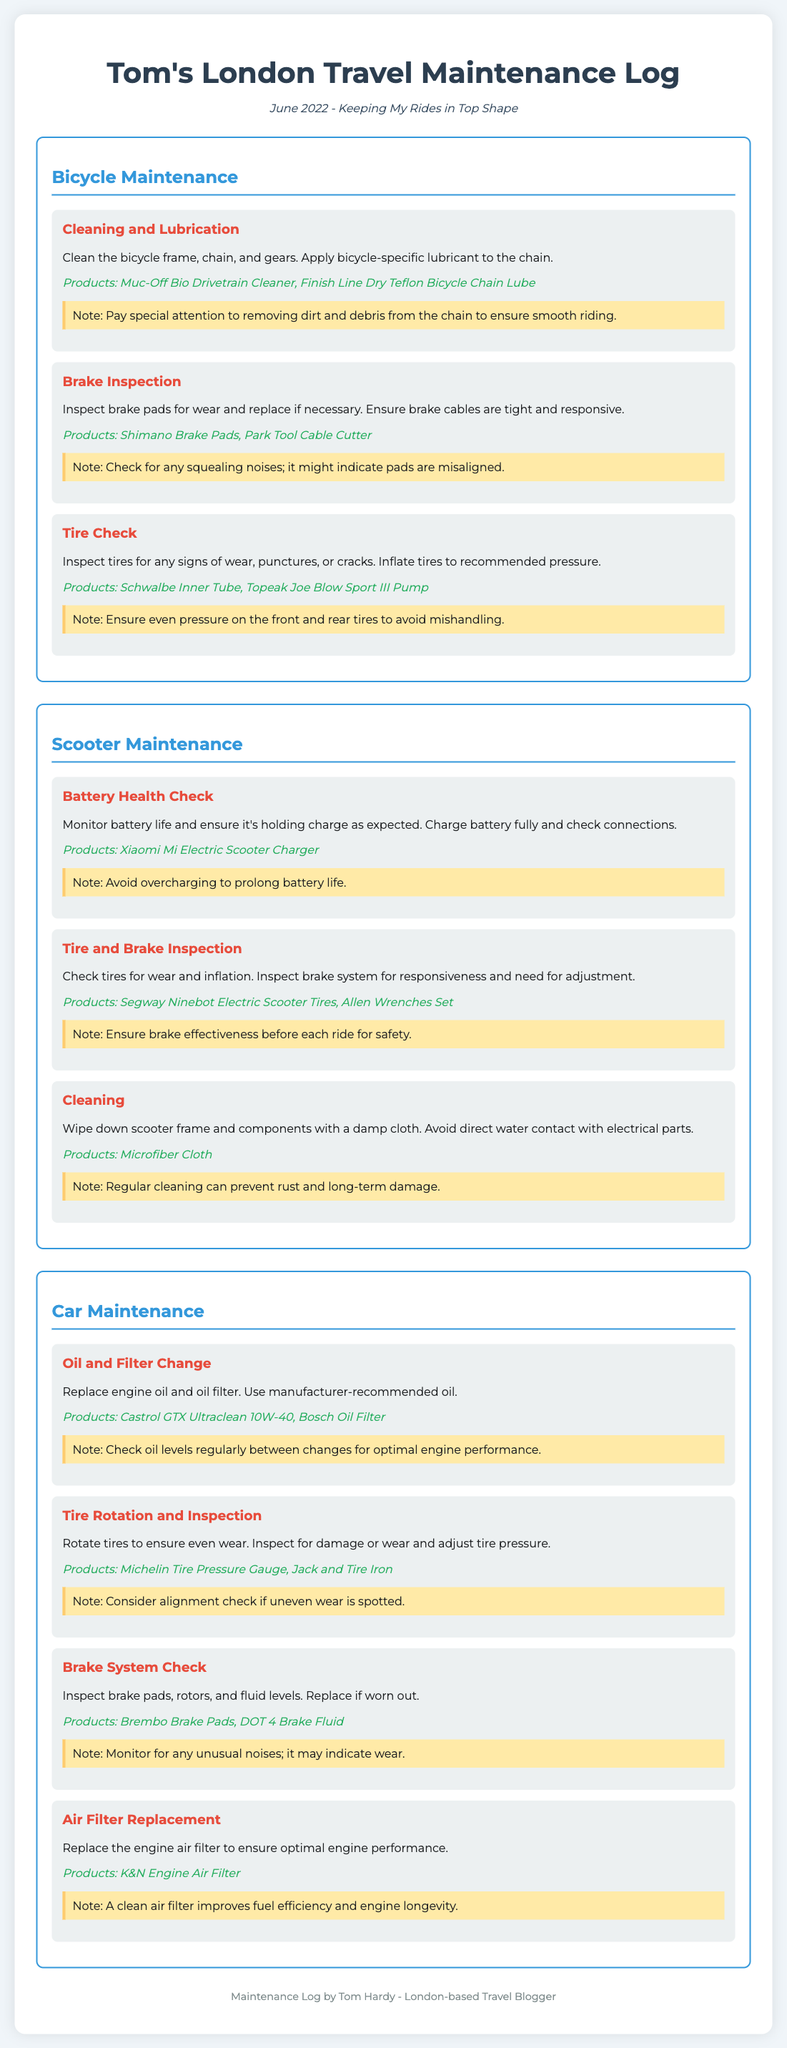What is the title of the document? The title of the document is provided in the header section, which indicates the name of the maintenance log.
Answer: Tom's London Travel Maintenance Log What month and year does the maintenance log cover? The subtitle under the title specifies the time period of the maintenance log.
Answer: June 2022 What product is used for cleaning the bicycle chain? The product mentioned in the bicycle maintenance tasks for lubricating the chain can be found in the task description.
Answer: Finish Line Dry Teflon Bicycle Chain Lube What health check is performed on the scooter? The first task under scooter maintenance indicates the type of health check that is conducted.
Answer: Battery Health Check How many tasks are listed under car maintenance? The number of tasks can be counted from the car maintenance section in the document.
Answer: Four Which product is recommended for the brake system check on the car? The appropriate product is specified in the task for the brake system check under car maintenance.
Answer: Brembo Brake Pads What should be inspected along with brake pads in scooter maintenance? The task emphasizes the importance of checking alongside brake pads in the scooter maintenance section.
Answer: Tires What is the note regarding tire pressure during bicycle tire checks? The note clarifies an important aspect of maintaining bicycle tire pressure that can be found below the task.
Answer: Ensure even pressure on the front and rear tires to avoid mishandling 